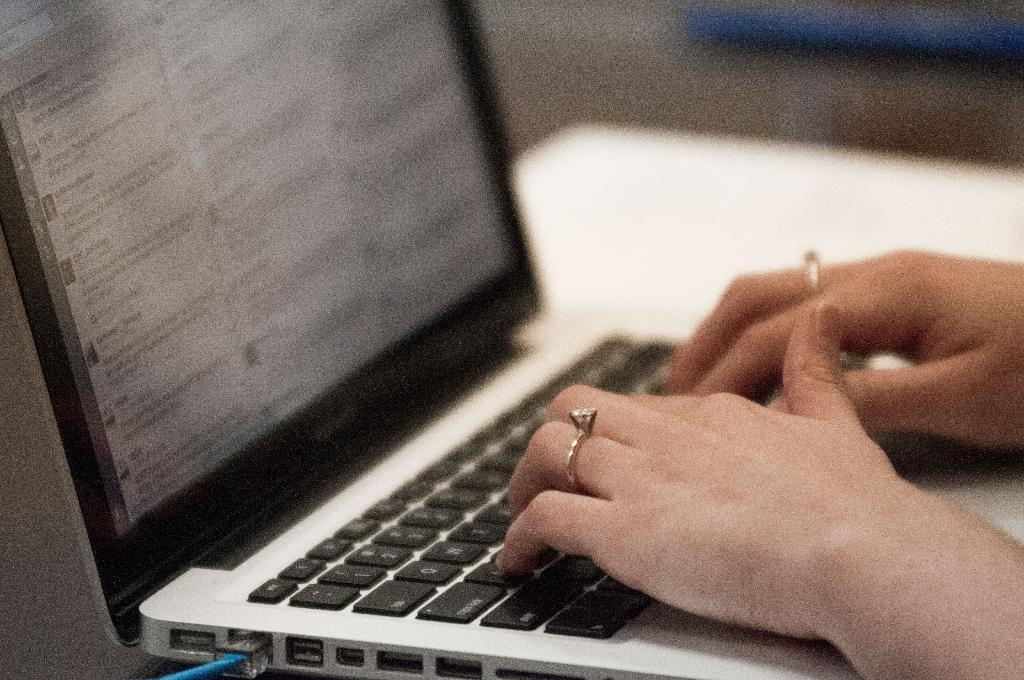<image>
Provide a brief description of the given image. A laptop computer with several words on it including USDA. 